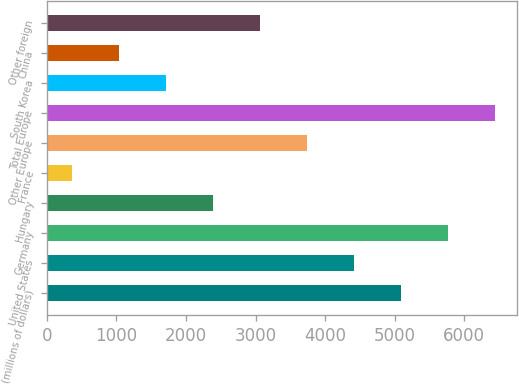Convert chart to OTSL. <chart><loc_0><loc_0><loc_500><loc_500><bar_chart><fcel>(millions of dollars)<fcel>United States<fcel>Germany<fcel>Hungary<fcel>France<fcel>Other Europe<fcel>Total Europe<fcel>South Korea<fcel>China<fcel>Other foreign<nl><fcel>5089.19<fcel>4414.02<fcel>5764.36<fcel>2388.51<fcel>363<fcel>3738.85<fcel>6439.53<fcel>1713.34<fcel>1038.17<fcel>3063.68<nl></chart> 